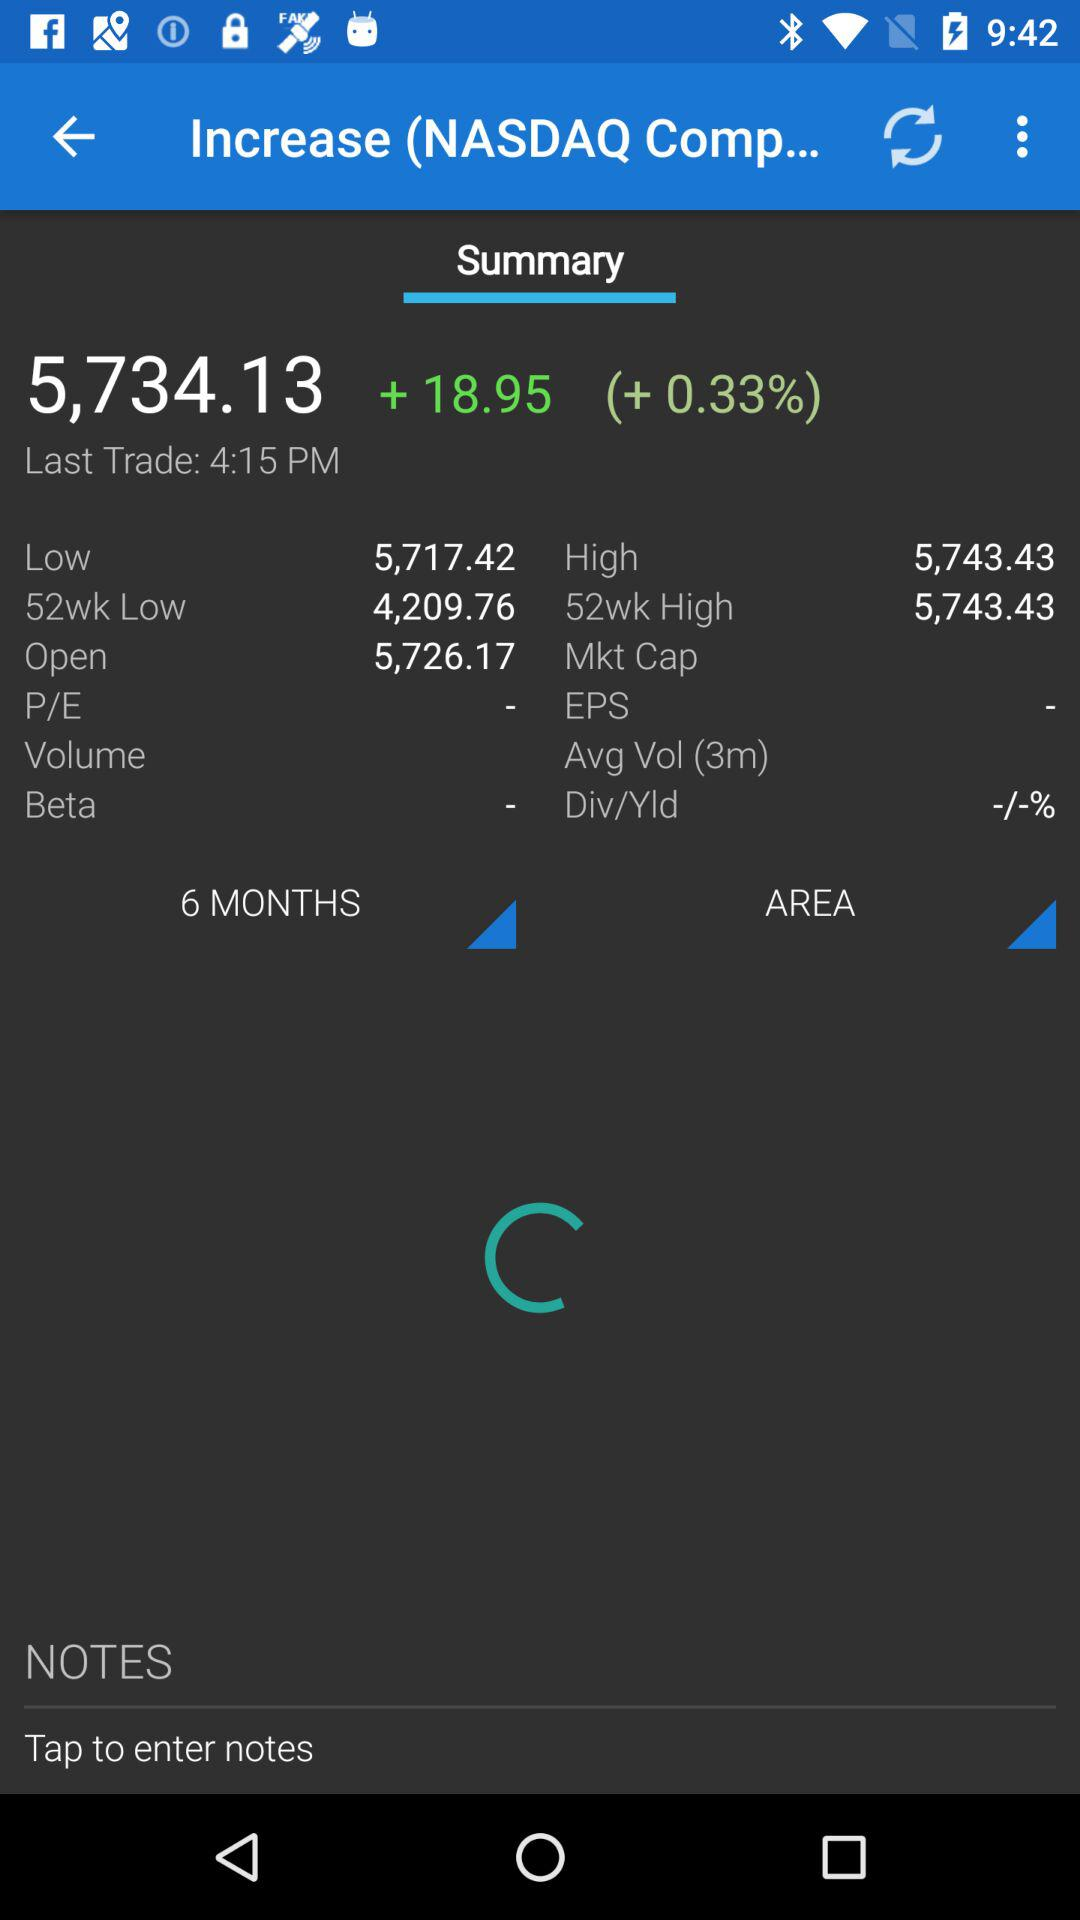What is the current price of the stock?
Answer the question using a single word or phrase. 5,734.13 